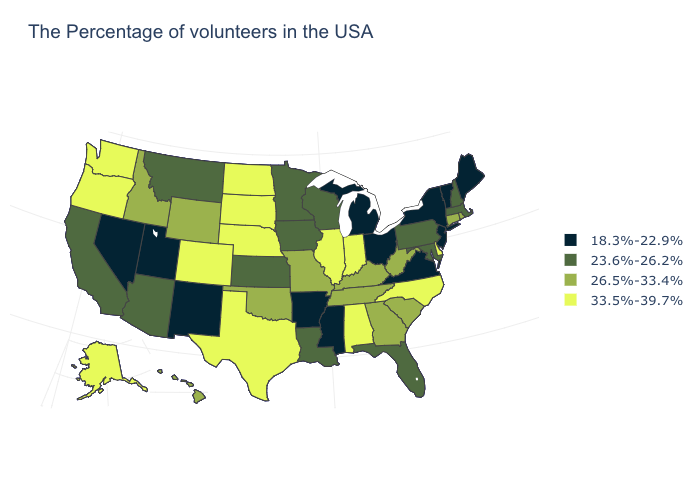Does South Carolina have a higher value than Utah?
Quick response, please. Yes. What is the value of Maine?
Concise answer only. 18.3%-22.9%. Does Rhode Island have a lower value than Kentucky?
Short answer required. No. Does Nevada have the highest value in the West?
Answer briefly. No. Does New Jersey have the highest value in the Northeast?
Write a very short answer. No. Among the states that border California , does Arizona have the lowest value?
Give a very brief answer. No. What is the value of Connecticut?
Be succinct. 26.5%-33.4%. What is the value of New Jersey?
Answer briefly. 18.3%-22.9%. Name the states that have a value in the range 18.3%-22.9%?
Give a very brief answer. Maine, Vermont, New York, New Jersey, Virginia, Ohio, Michigan, Mississippi, Arkansas, New Mexico, Utah, Nevada. What is the value of Ohio?
Keep it brief. 18.3%-22.9%. Among the states that border Vermont , does New Hampshire have the lowest value?
Keep it brief. No. Does Nebraska have the same value as Oregon?
Quick response, please. Yes. Does the first symbol in the legend represent the smallest category?
Be succinct. Yes. Among the states that border Florida , does Georgia have the highest value?
Keep it brief. No. What is the value of North Dakota?
Quick response, please. 33.5%-39.7%. 